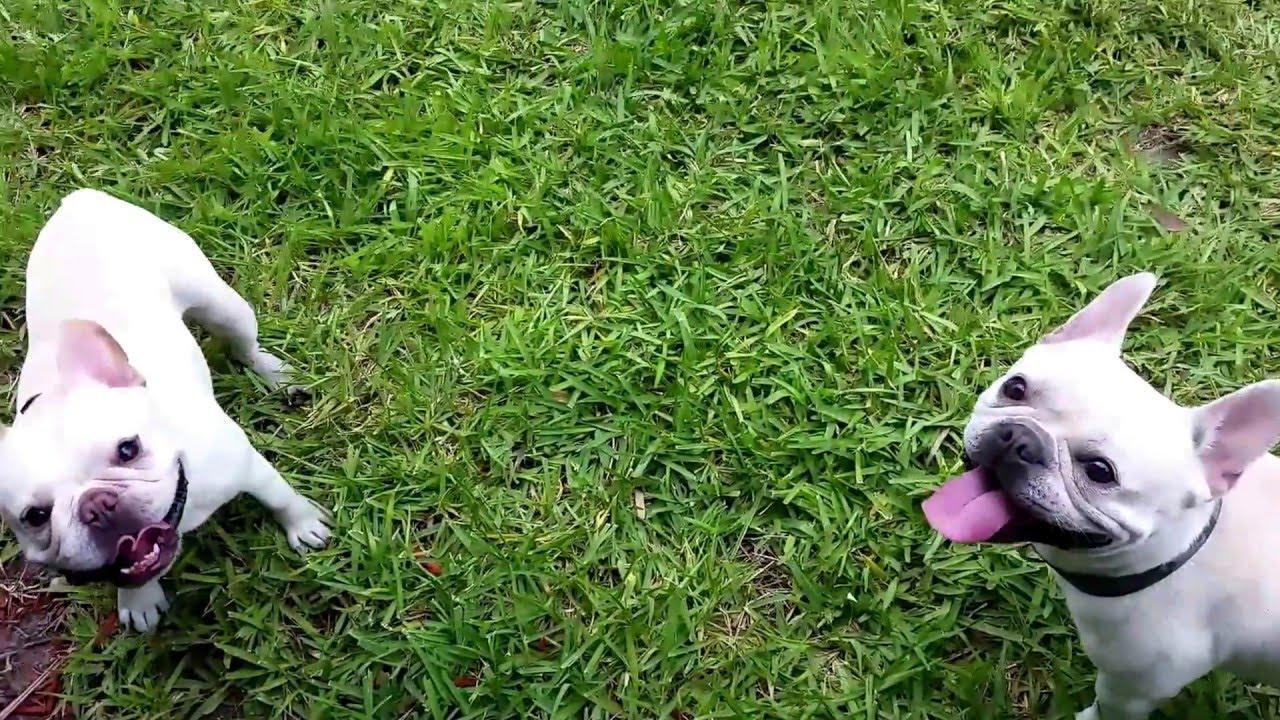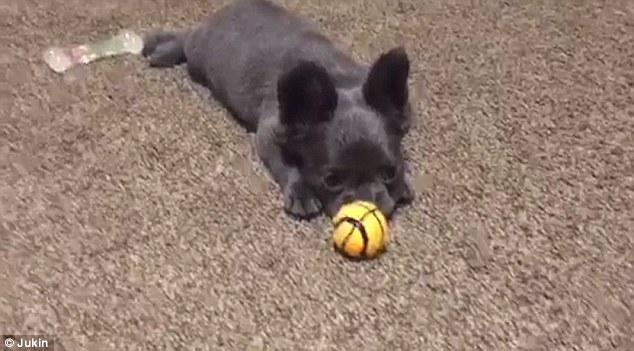The first image is the image on the left, the second image is the image on the right. Considering the images on both sides, is "The dog in the image on the right is playing with a yellow ball." valid? Answer yes or no. Yes. The first image is the image on the left, the second image is the image on the right. For the images displayed, is the sentence "An image shows a brown dog playing with a yellow tennis ball in an area with green ground." factually correct? Answer yes or no. No. 